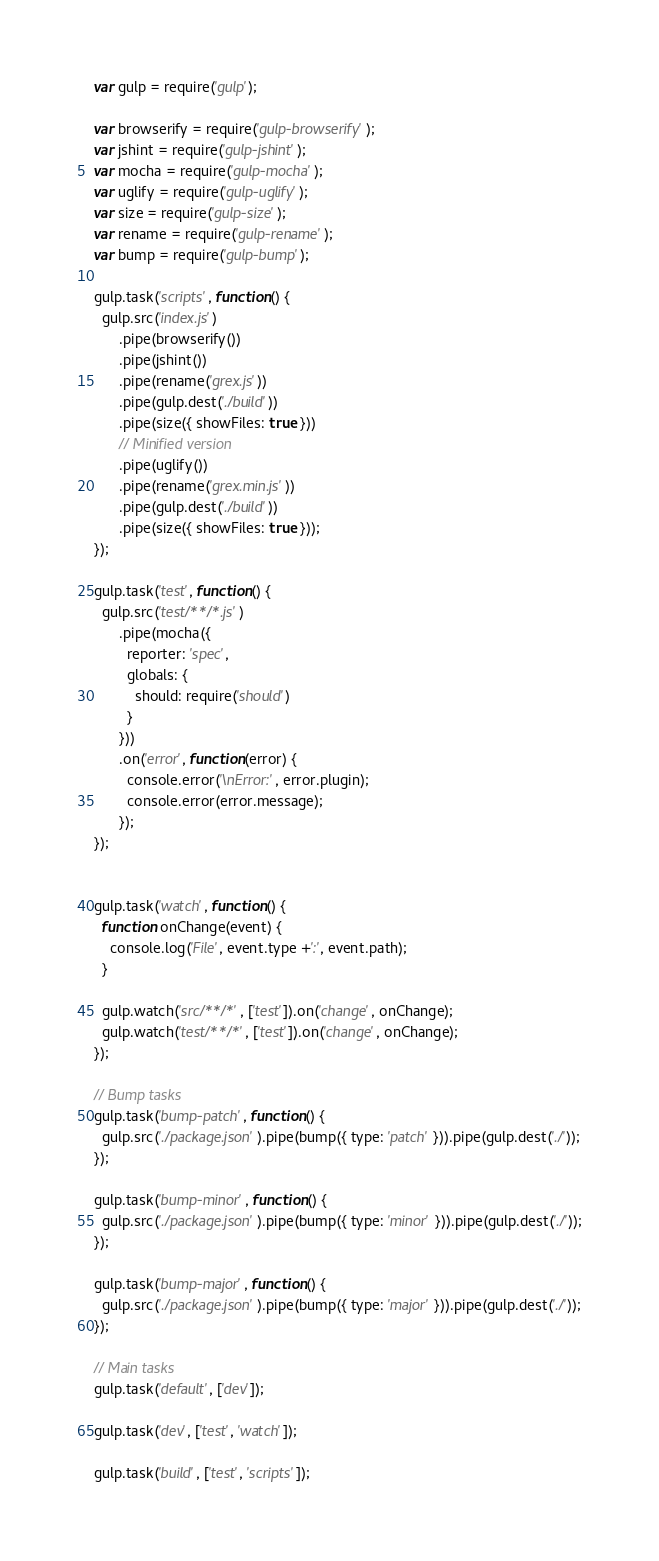<code> <loc_0><loc_0><loc_500><loc_500><_JavaScript_>var gulp = require('gulp');

var browserify = require('gulp-browserify');
var jshint = require('gulp-jshint');
var mocha = require('gulp-mocha');
var uglify = require('gulp-uglify');
var size = require('gulp-size');
var rename = require('gulp-rename');
var bump = require('gulp-bump');

gulp.task('scripts', function() {
  gulp.src('index.js')
      .pipe(browserify())
      .pipe(jshint())
      .pipe(rename('grex.js'))
      .pipe(gulp.dest('./build'))
      .pipe(size({ showFiles: true }))
      // Minified version
      .pipe(uglify())
      .pipe(rename('grex.min.js'))
      .pipe(gulp.dest('./build'))
      .pipe(size({ showFiles: true }));
});

gulp.task('test', function() {
  gulp.src('test/**/*.js')
      .pipe(mocha({
        reporter: 'spec',
        globals: {
          should: require('should')
        }
      }))
      .on('error', function(error) {
        console.error('\nError:', error.plugin);
        console.error(error.message);
      });
});


gulp.task('watch', function() {
  function onChange(event) {
    console.log('File', event.type +':', event.path);
  }

  gulp.watch('src/**/*', ['test']).on('change', onChange);
  gulp.watch('test/**/*', ['test']).on('change', onChange);
});

// Bump tasks
gulp.task('bump-patch', function() {
  gulp.src('./package.json').pipe(bump({ type: 'patch' })).pipe(gulp.dest('./'));
});

gulp.task('bump-minor', function() {
  gulp.src('./package.json').pipe(bump({ type: 'minor' })).pipe(gulp.dest('./'));
});

gulp.task('bump-major', function() {
  gulp.src('./package.json').pipe(bump({ type: 'major' })).pipe(gulp.dest('./'));
});

// Main tasks
gulp.task('default', ['dev']);

gulp.task('dev', ['test', 'watch']);

gulp.task('build', ['test', 'scripts']);

</code> 